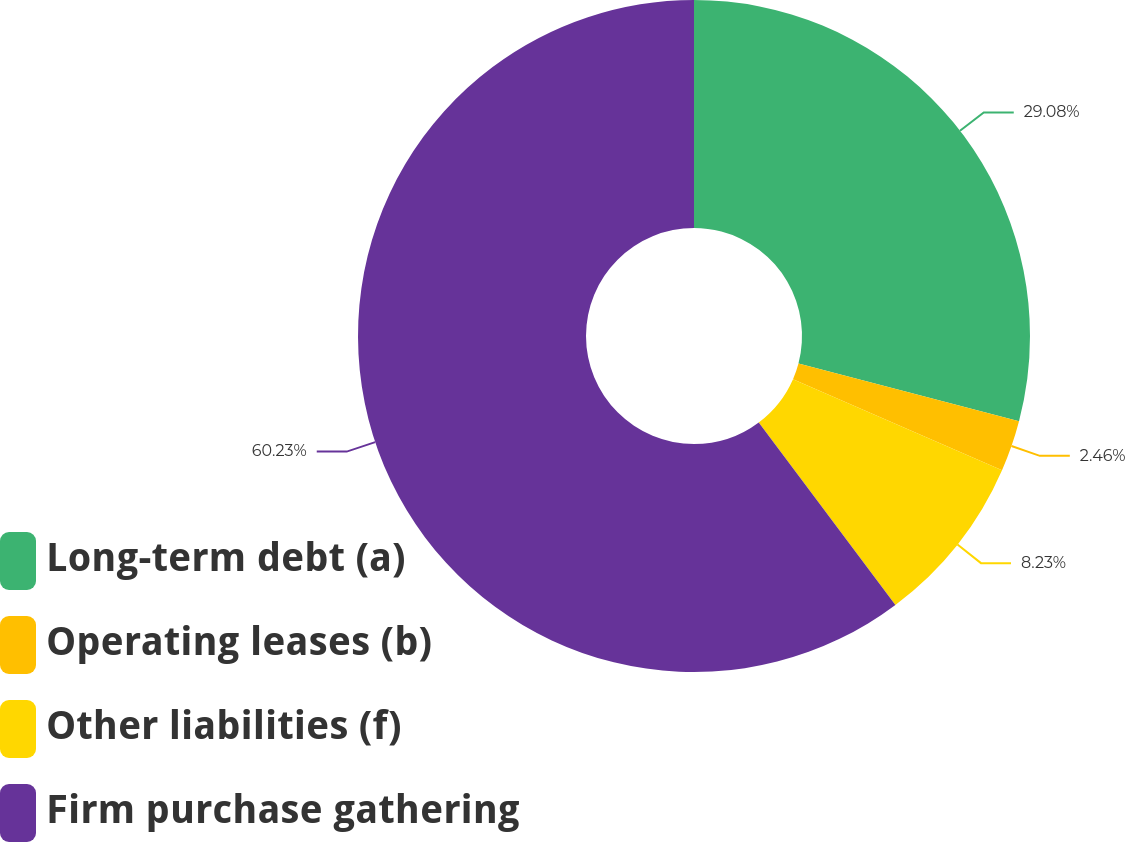Convert chart to OTSL. <chart><loc_0><loc_0><loc_500><loc_500><pie_chart><fcel>Long-term debt (a)<fcel>Operating leases (b)<fcel>Other liabilities (f)<fcel>Firm purchase gathering<nl><fcel>29.08%<fcel>2.46%<fcel>8.23%<fcel>60.23%<nl></chart> 